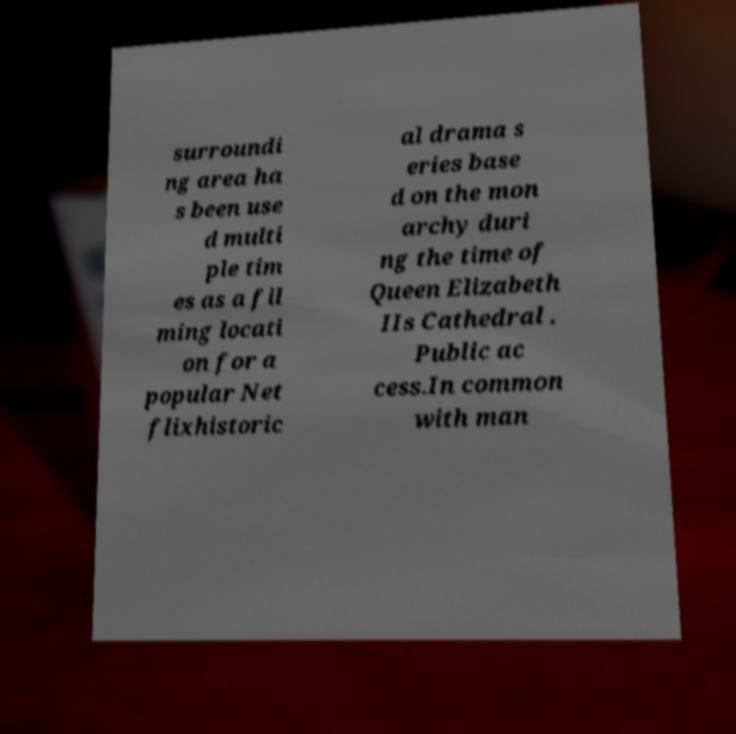Could you assist in decoding the text presented in this image and type it out clearly? surroundi ng area ha s been use d multi ple tim es as a fil ming locati on for a popular Net flixhistoric al drama s eries base d on the mon archy duri ng the time of Queen Elizabeth IIs Cathedral . Public ac cess.In common with man 